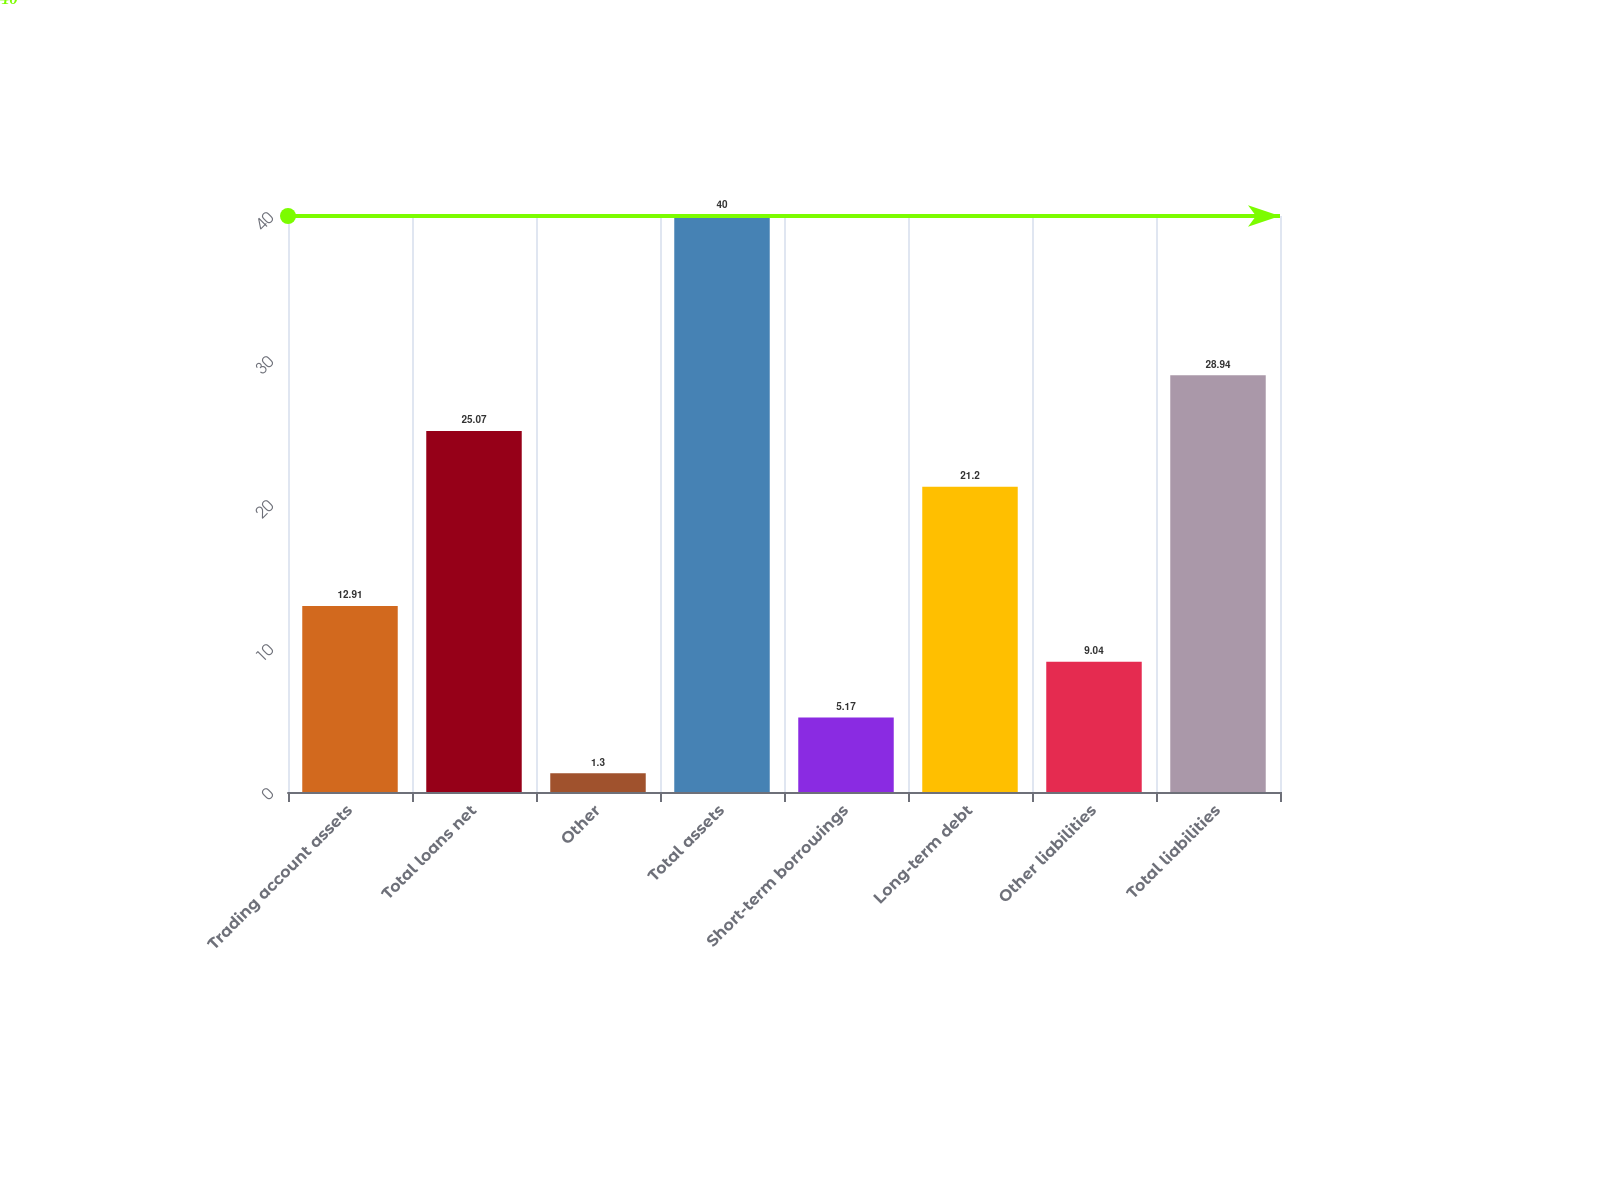Convert chart to OTSL. <chart><loc_0><loc_0><loc_500><loc_500><bar_chart><fcel>Trading account assets<fcel>Total loans net<fcel>Other<fcel>Total assets<fcel>Short-term borrowings<fcel>Long-term debt<fcel>Other liabilities<fcel>Total liabilities<nl><fcel>12.91<fcel>25.07<fcel>1.3<fcel>40<fcel>5.17<fcel>21.2<fcel>9.04<fcel>28.94<nl></chart> 